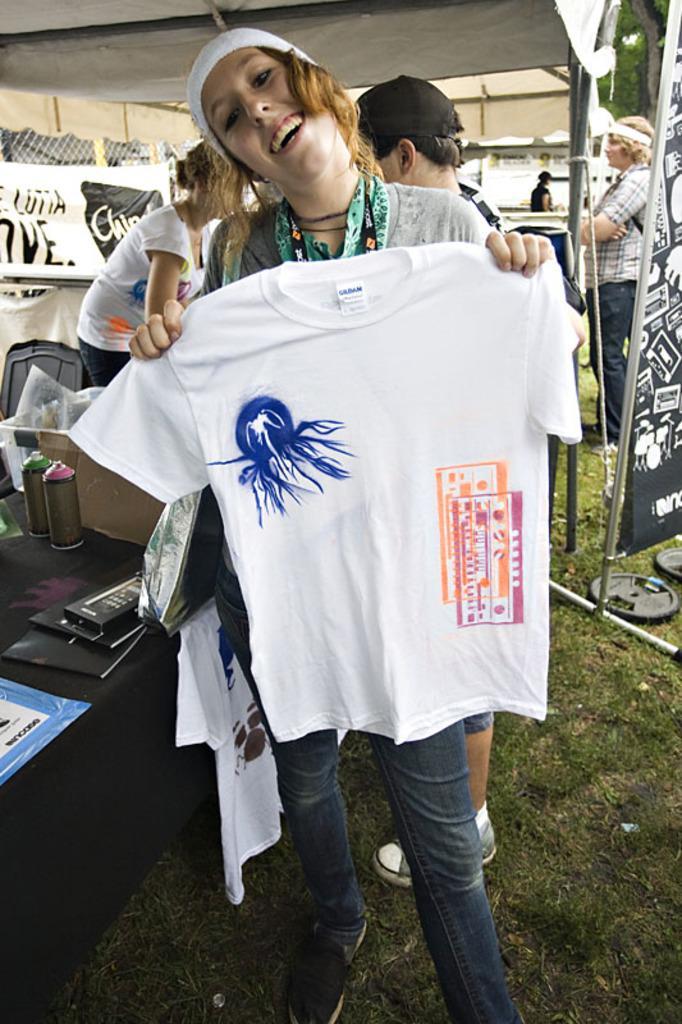Can you describe this image briefly? Here I can see a woman standing, holding a t-shirt in the hands, smiling and giving pose for the picture. At the bottom of the image I can see the grass. At the back of her there are some more people standing and also there is a table which is covered with a black color cloth. On the table I can see few books, bottles and boxes. At the top I can see a white color tint. In the background there are some trees. 